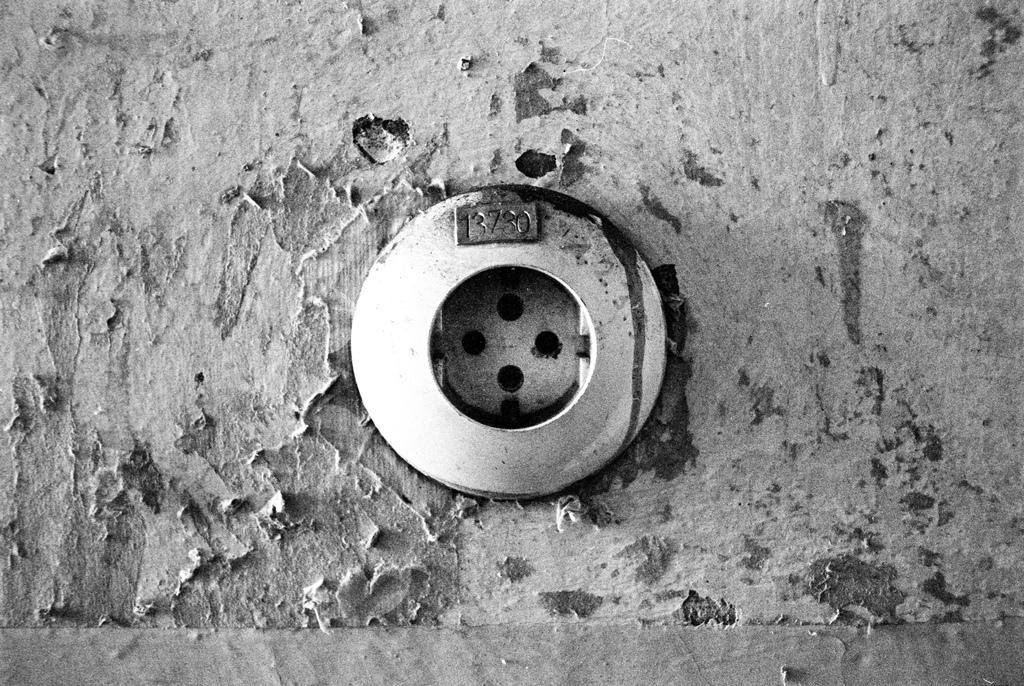<image>
Offer a succinct explanation of the picture presented. A picture of a drain with the number 13730 